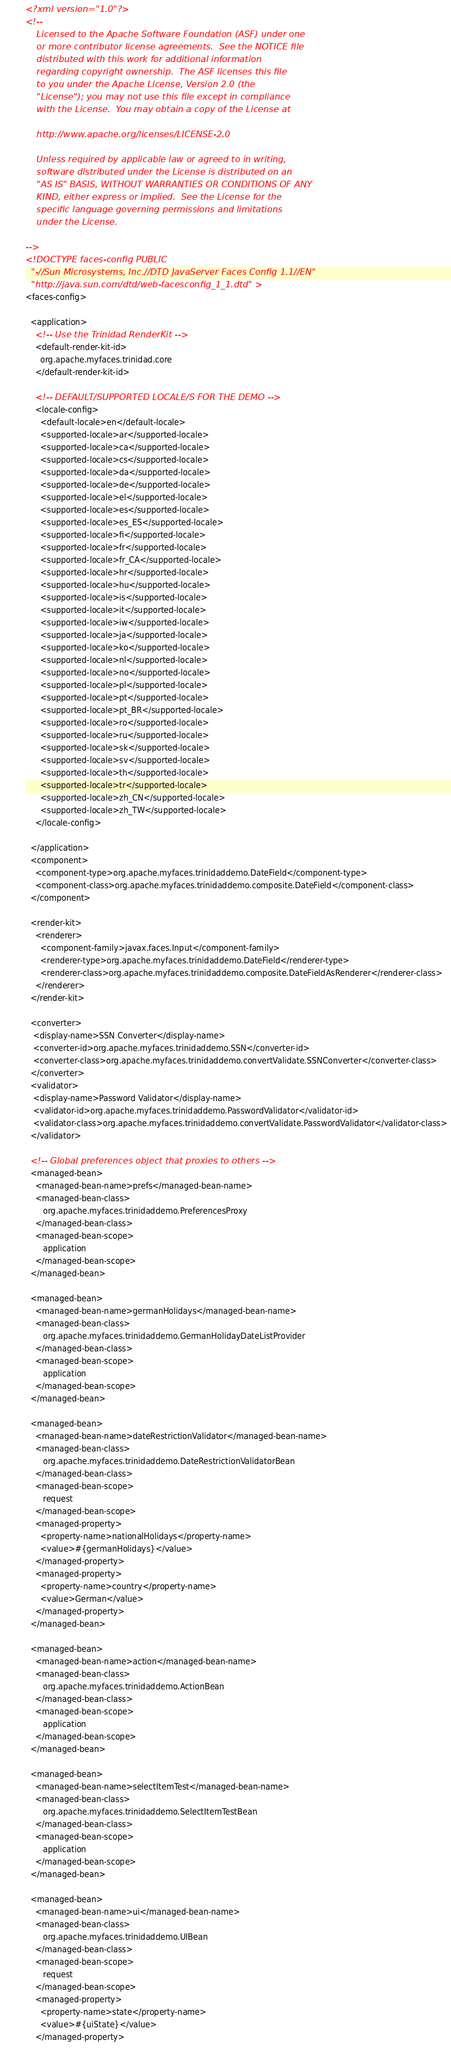Convert code to text. <code><loc_0><loc_0><loc_500><loc_500><_XML_><?xml version="1.0"?>
<!--
    Licensed to the Apache Software Foundation (ASF) under one
    or more contributor license agreements.  See the NOTICE file
    distributed with this work for additional information
    regarding copyright ownership.  The ASF licenses this file
    to you under the Apache License, Version 2.0 (the
    "License"); you may not use this file except in compliance
    with the License.  You may obtain a copy of the License at

    http://www.apache.org/licenses/LICENSE-2.0

    Unless required by applicable law or agreed to in writing,
    software distributed under the License is distributed on an
    "AS IS" BASIS, WITHOUT WARRANTIES OR CONDITIONS OF ANY
    KIND, either express or implied.  See the License for the
    specific language governing permissions and limitations
    under the License.
	   
-->
<!DOCTYPE faces-config PUBLIC
  "-//Sun Microsystems, Inc.//DTD JavaServer Faces Config 1.1//EN"
  "http://java.sun.com/dtd/web-facesconfig_1_1.dtd" >
<faces-config>
  
  <application>
    <!-- Use the Trinidad RenderKit -->
    <default-render-kit-id>
      org.apache.myfaces.trinidad.core
    </default-render-kit-id>

    <!-- DEFAULT/SUPPORTED LOCALE/S FOR THE DEMO -->
    <locale-config>
      <default-locale>en</default-locale>
      <supported-locale>ar</supported-locale>
      <supported-locale>ca</supported-locale>
      <supported-locale>cs</supported-locale>
      <supported-locale>da</supported-locale>
      <supported-locale>de</supported-locale>
      <supported-locale>el</supported-locale>
      <supported-locale>es</supported-locale>
      <supported-locale>es_ES</supported-locale>
      <supported-locale>fi</supported-locale>
      <supported-locale>fr</supported-locale>
      <supported-locale>fr_CA</supported-locale>
      <supported-locale>hr</supported-locale>
      <supported-locale>hu</supported-locale>
      <supported-locale>is</supported-locale>
      <supported-locale>it</supported-locale>
      <supported-locale>iw</supported-locale>
      <supported-locale>ja</supported-locale>
      <supported-locale>ko</supported-locale>
      <supported-locale>nl</supported-locale>
      <supported-locale>no</supported-locale>
      <supported-locale>pl</supported-locale>
      <supported-locale>pt</supported-locale>
      <supported-locale>pt_BR</supported-locale>
      <supported-locale>ro</supported-locale>
      <supported-locale>ru</supported-locale>
      <supported-locale>sk</supported-locale>
      <supported-locale>sv</supported-locale>
      <supported-locale>th</supported-locale>
      <supported-locale>tr</supported-locale>
      <supported-locale>zh_CN</supported-locale>
      <supported-locale>zh_TW</supported-locale>
    </locale-config>
  
  </application>
  <component>
    <component-type>org.apache.myfaces.trinidaddemo.DateField</component-type>
    <component-class>org.apache.myfaces.trinidaddemo.composite.DateField</component-class>
  </component>

  <render-kit>
    <renderer>
      <component-family>javax.faces.Input</component-family>
      <renderer-type>org.apache.myfaces.trinidaddemo.DateField</renderer-type>
      <renderer-class>org.apache.myfaces.trinidaddemo.composite.DateFieldAsRenderer</renderer-class>
    </renderer>
  </render-kit>

  <converter>
   <display-name>SSN Converter</display-name>
   <converter-id>org.apache.myfaces.trinidaddemo.SSN</converter-id>
   <converter-class>org.apache.myfaces.trinidaddemo.convertValidate.SSNConverter</converter-class>
  </converter>
  <validator>
   <display-name>Password Validator</display-name>
   <validator-id>org.apache.myfaces.trinidaddemo.PasswordValidator</validator-id>
   <validator-class>org.apache.myfaces.trinidaddemo.convertValidate.PasswordValidator</validator-class>
  </validator>
    
  <!-- Global preferences object that proxies to others -->
  <managed-bean>
    <managed-bean-name>prefs</managed-bean-name>
    <managed-bean-class>
       org.apache.myfaces.trinidaddemo.PreferencesProxy
    </managed-bean-class>
    <managed-bean-scope>
       application
    </managed-bean-scope>
  </managed-bean>

  <managed-bean>
    <managed-bean-name>germanHolidays</managed-bean-name>
    <managed-bean-class>
       org.apache.myfaces.trinidaddemo.GermanHolidayDateListProvider
    </managed-bean-class>
    <managed-bean-scope>
       application
    </managed-bean-scope>
  </managed-bean>
  
  <managed-bean>
    <managed-bean-name>dateRestrictionValidator</managed-bean-name>
    <managed-bean-class>
       org.apache.myfaces.trinidaddemo.DateRestrictionValidatorBean
    </managed-bean-class>
    <managed-bean-scope>
       request
    </managed-bean-scope>
    <managed-property>
      <property-name>nationalHolidays</property-name>
      <value>#{germanHolidays}</value>
    </managed-property>
    <managed-property>
      <property-name>country</property-name>
      <value>German</value>
    </managed-property>
  </managed-bean>

  <managed-bean>
    <managed-bean-name>action</managed-bean-name>
    <managed-bean-class>
       org.apache.myfaces.trinidaddemo.ActionBean
    </managed-bean-class>
    <managed-bean-scope>
       application
    </managed-bean-scope>
  </managed-bean>

  <managed-bean>
    <managed-bean-name>selectItemTest</managed-bean-name>
    <managed-bean-class>
       org.apache.myfaces.trinidaddemo.SelectItemTestBean
    </managed-bean-class>
    <managed-bean-scope>
       application
    </managed-bean-scope>
  </managed-bean>

  <managed-bean>
    <managed-bean-name>ui</managed-bean-name>
    <managed-bean-class>
       org.apache.myfaces.trinidaddemo.UIBean
    </managed-bean-class>
    <managed-bean-scope>
       request
    </managed-bean-scope>
    <managed-property>
      <property-name>state</property-name>
      <value>#{uiState}</value>
    </managed-property></code> 